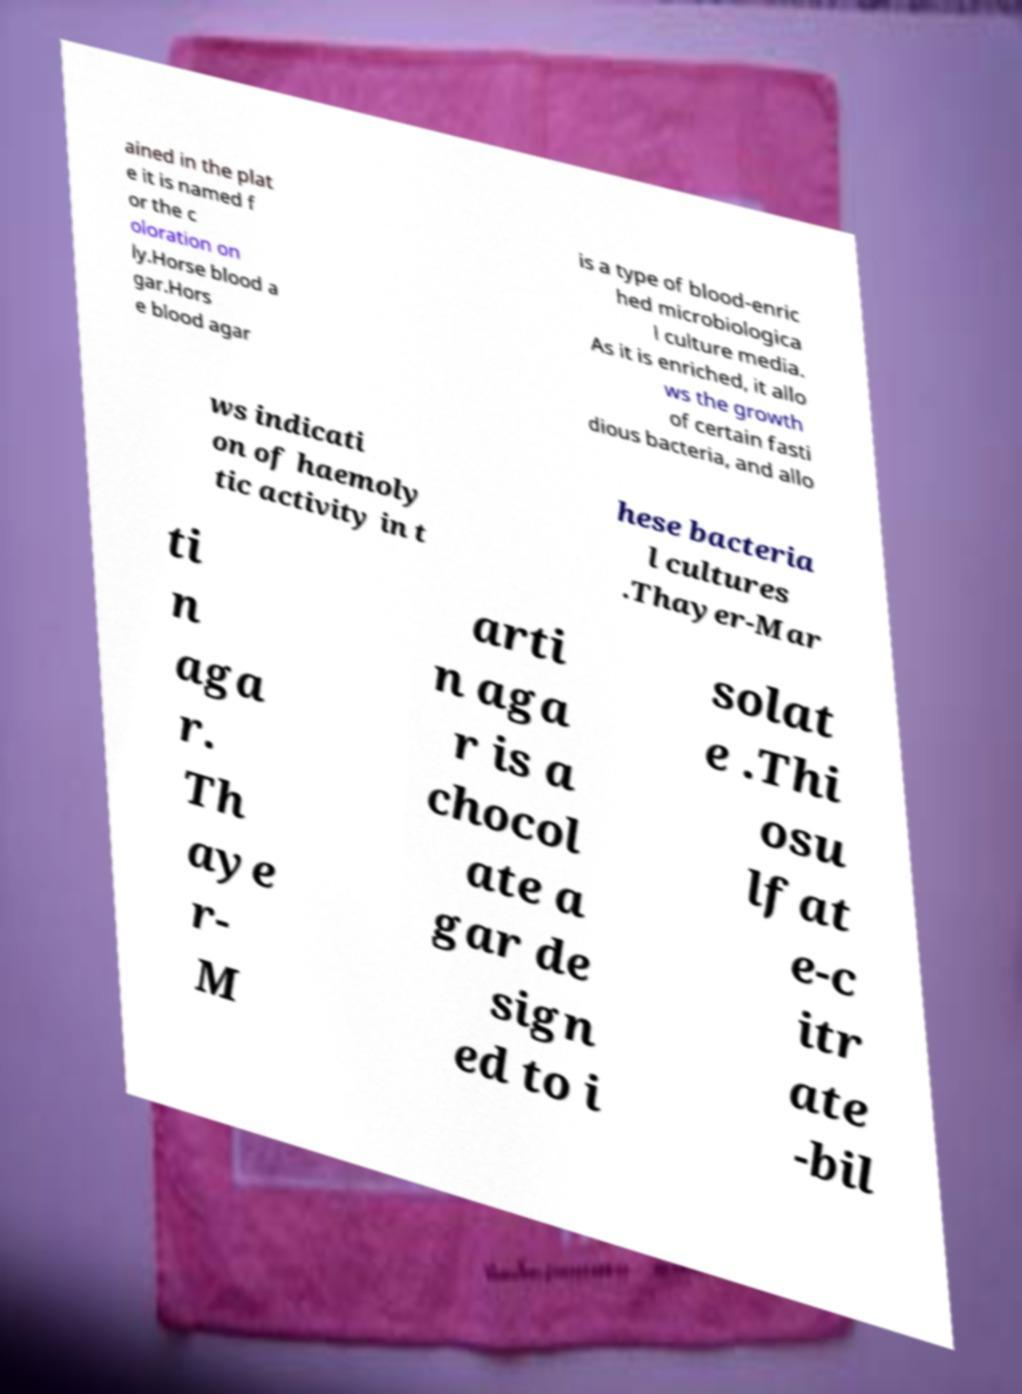Please identify and transcribe the text found in this image. ained in the plat e it is named f or the c oloration on ly.Horse blood a gar.Hors e blood agar is a type of blood-enric hed microbiologica l culture media. As it is enriched, it allo ws the growth of certain fasti dious bacteria, and allo ws indicati on of haemoly tic activity in t hese bacteria l cultures .Thayer-Mar ti n aga r. Th aye r- M arti n aga r is a chocol ate a gar de sign ed to i solat e .Thi osu lfat e-c itr ate -bil 